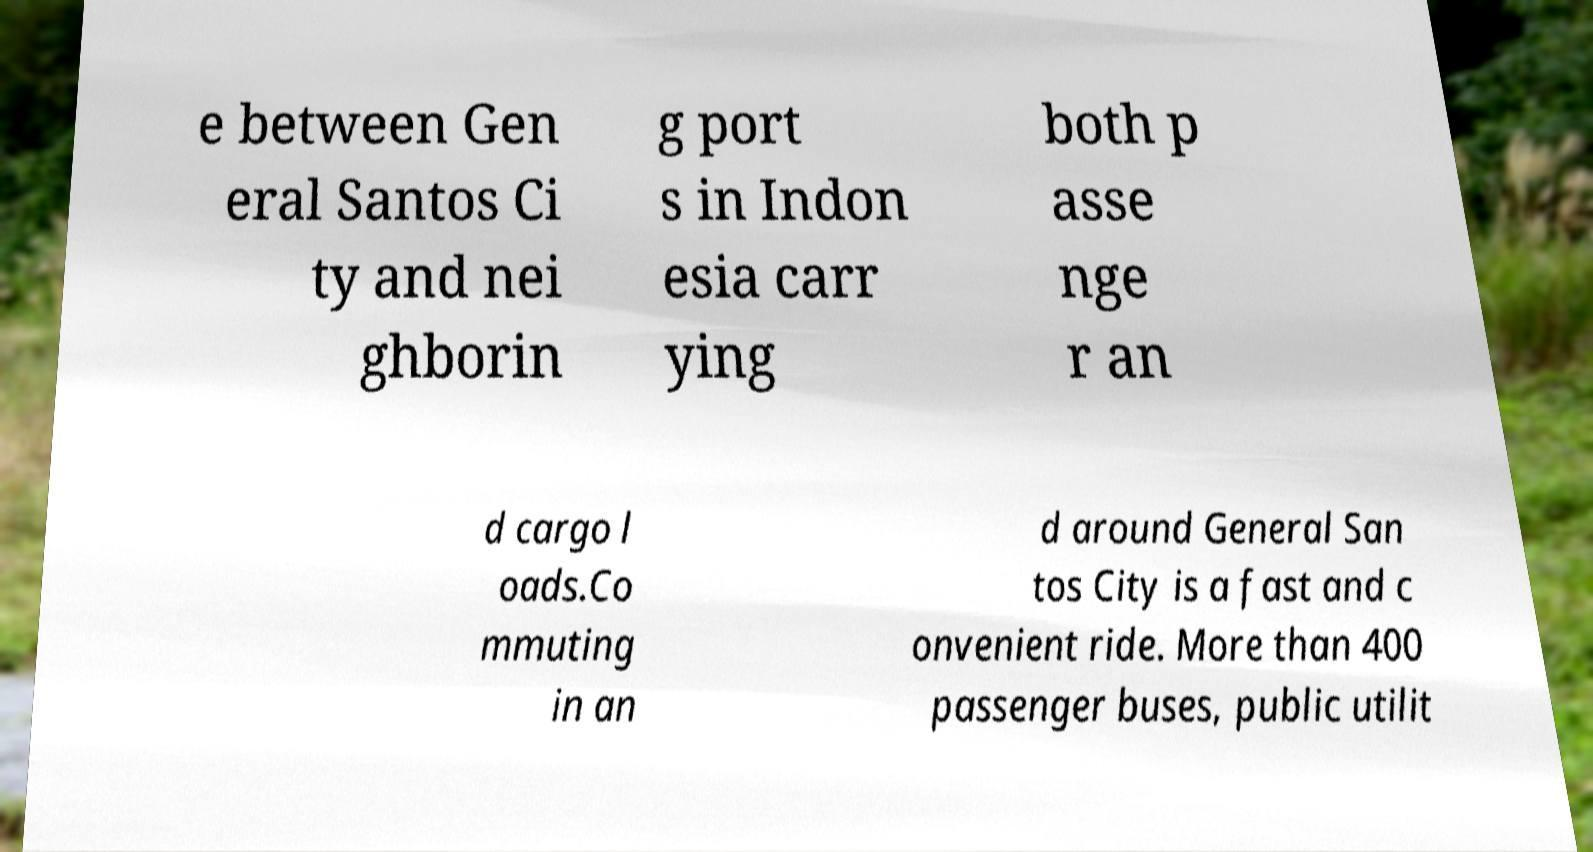Could you assist in decoding the text presented in this image and type it out clearly? e between Gen eral Santos Ci ty and nei ghborin g port s in Indon esia carr ying both p asse nge r an d cargo l oads.Co mmuting in an d around General San tos City is a fast and c onvenient ride. More than 400 passenger buses, public utilit 